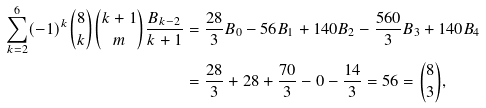Convert formula to latex. <formula><loc_0><loc_0><loc_500><loc_500>\sum _ { k = 2 } ^ { 6 } ( - 1 ) ^ { k } \binom { 8 } { k } \binom { k + 1 } { m } \frac { B _ { k - 2 } } { k + 1 } & = \frac { 2 8 } { 3 } B _ { 0 } - 5 6 B _ { 1 } + 1 4 0 B _ { 2 } - \frac { 5 6 0 } { 3 } B _ { 3 } + 1 4 0 B _ { 4 } \\ & = \frac { 2 8 } { 3 } + 2 8 + \frac { 7 0 } { 3 } - 0 - \frac { 1 4 } { 3 } = 5 6 = \binom { 8 } { 3 } ,</formula> 